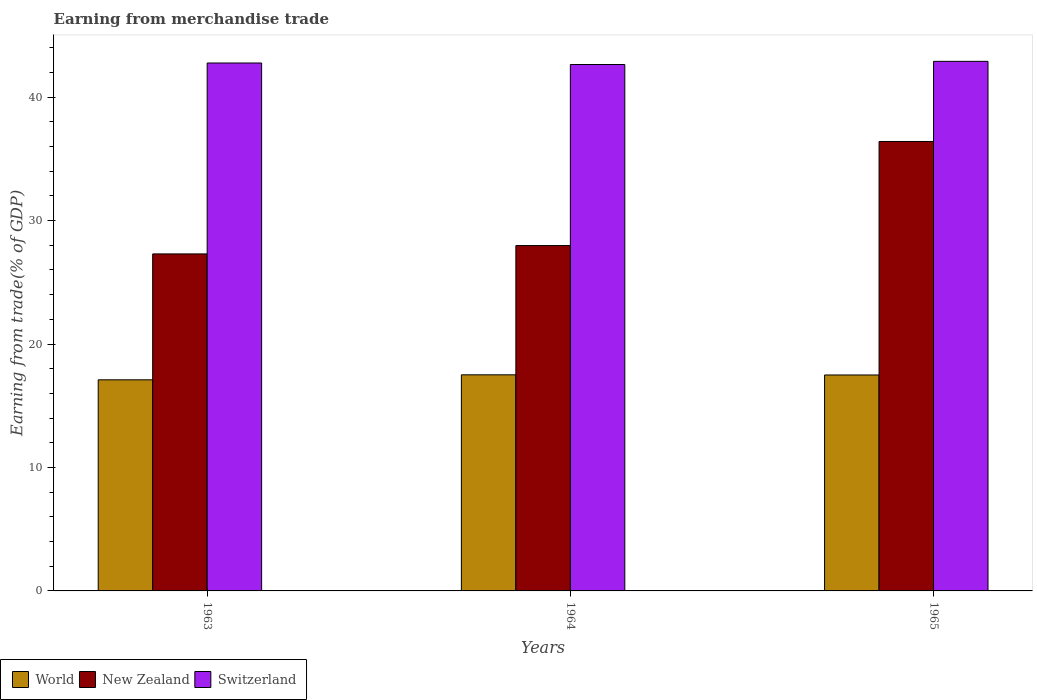How many different coloured bars are there?
Give a very brief answer. 3. Are the number of bars per tick equal to the number of legend labels?
Offer a terse response. Yes. What is the label of the 3rd group of bars from the left?
Give a very brief answer. 1965. In how many cases, is the number of bars for a given year not equal to the number of legend labels?
Your answer should be very brief. 0. What is the earnings from trade in New Zealand in 1963?
Give a very brief answer. 27.3. Across all years, what is the maximum earnings from trade in Switzerland?
Provide a short and direct response. 42.9. Across all years, what is the minimum earnings from trade in Switzerland?
Give a very brief answer. 42.64. In which year was the earnings from trade in New Zealand maximum?
Make the answer very short. 1965. In which year was the earnings from trade in World minimum?
Ensure brevity in your answer.  1963. What is the total earnings from trade in World in the graph?
Ensure brevity in your answer.  52.1. What is the difference between the earnings from trade in Switzerland in 1963 and that in 1965?
Your answer should be compact. -0.13. What is the difference between the earnings from trade in Switzerland in 1965 and the earnings from trade in World in 1963?
Provide a short and direct response. 25.8. What is the average earnings from trade in World per year?
Provide a short and direct response. 17.37. In the year 1965, what is the difference between the earnings from trade in Switzerland and earnings from trade in World?
Provide a short and direct response. 25.41. In how many years, is the earnings from trade in New Zealand greater than 28 %?
Keep it short and to the point. 1. What is the ratio of the earnings from trade in New Zealand in 1963 to that in 1965?
Your answer should be compact. 0.75. Is the difference between the earnings from trade in Switzerland in 1963 and 1964 greater than the difference between the earnings from trade in World in 1963 and 1964?
Offer a terse response. Yes. What is the difference between the highest and the second highest earnings from trade in Switzerland?
Ensure brevity in your answer.  0.13. What is the difference between the highest and the lowest earnings from trade in New Zealand?
Give a very brief answer. 9.11. What does the 1st bar from the left in 1964 represents?
Offer a terse response. World. What does the 1st bar from the right in 1963 represents?
Your response must be concise. Switzerland. Are all the bars in the graph horizontal?
Offer a very short reply. No. Does the graph contain any zero values?
Offer a terse response. No. Does the graph contain grids?
Make the answer very short. No. Where does the legend appear in the graph?
Give a very brief answer. Bottom left. How many legend labels are there?
Your answer should be very brief. 3. How are the legend labels stacked?
Give a very brief answer. Horizontal. What is the title of the graph?
Offer a terse response. Earning from merchandise trade. Does "Nicaragua" appear as one of the legend labels in the graph?
Provide a short and direct response. No. What is the label or title of the Y-axis?
Keep it short and to the point. Earning from trade(% of GDP). What is the Earning from trade(% of GDP) of World in 1963?
Give a very brief answer. 17.1. What is the Earning from trade(% of GDP) in New Zealand in 1963?
Keep it short and to the point. 27.3. What is the Earning from trade(% of GDP) in Switzerland in 1963?
Ensure brevity in your answer.  42.77. What is the Earning from trade(% of GDP) of World in 1964?
Provide a short and direct response. 17.51. What is the Earning from trade(% of GDP) of New Zealand in 1964?
Keep it short and to the point. 27.98. What is the Earning from trade(% of GDP) of Switzerland in 1964?
Your answer should be compact. 42.64. What is the Earning from trade(% of GDP) in World in 1965?
Ensure brevity in your answer.  17.49. What is the Earning from trade(% of GDP) in New Zealand in 1965?
Your response must be concise. 36.41. What is the Earning from trade(% of GDP) of Switzerland in 1965?
Ensure brevity in your answer.  42.9. Across all years, what is the maximum Earning from trade(% of GDP) of World?
Your answer should be compact. 17.51. Across all years, what is the maximum Earning from trade(% of GDP) of New Zealand?
Keep it short and to the point. 36.41. Across all years, what is the maximum Earning from trade(% of GDP) in Switzerland?
Provide a succinct answer. 42.9. Across all years, what is the minimum Earning from trade(% of GDP) of World?
Your answer should be very brief. 17.1. Across all years, what is the minimum Earning from trade(% of GDP) of New Zealand?
Keep it short and to the point. 27.3. Across all years, what is the minimum Earning from trade(% of GDP) in Switzerland?
Offer a terse response. 42.64. What is the total Earning from trade(% of GDP) in World in the graph?
Give a very brief answer. 52.1. What is the total Earning from trade(% of GDP) in New Zealand in the graph?
Your answer should be very brief. 91.69. What is the total Earning from trade(% of GDP) in Switzerland in the graph?
Keep it short and to the point. 128.31. What is the difference between the Earning from trade(% of GDP) of World in 1963 and that in 1964?
Offer a very short reply. -0.41. What is the difference between the Earning from trade(% of GDP) in New Zealand in 1963 and that in 1964?
Provide a succinct answer. -0.68. What is the difference between the Earning from trade(% of GDP) of Switzerland in 1963 and that in 1964?
Offer a very short reply. 0.12. What is the difference between the Earning from trade(% of GDP) of World in 1963 and that in 1965?
Offer a very short reply. -0.39. What is the difference between the Earning from trade(% of GDP) of New Zealand in 1963 and that in 1965?
Offer a terse response. -9.11. What is the difference between the Earning from trade(% of GDP) of Switzerland in 1963 and that in 1965?
Your answer should be compact. -0.13. What is the difference between the Earning from trade(% of GDP) of World in 1964 and that in 1965?
Ensure brevity in your answer.  0.01. What is the difference between the Earning from trade(% of GDP) of New Zealand in 1964 and that in 1965?
Provide a succinct answer. -8.43. What is the difference between the Earning from trade(% of GDP) in Switzerland in 1964 and that in 1965?
Your response must be concise. -0.26. What is the difference between the Earning from trade(% of GDP) of World in 1963 and the Earning from trade(% of GDP) of New Zealand in 1964?
Provide a short and direct response. -10.88. What is the difference between the Earning from trade(% of GDP) in World in 1963 and the Earning from trade(% of GDP) in Switzerland in 1964?
Your answer should be compact. -25.54. What is the difference between the Earning from trade(% of GDP) in New Zealand in 1963 and the Earning from trade(% of GDP) in Switzerland in 1964?
Ensure brevity in your answer.  -15.34. What is the difference between the Earning from trade(% of GDP) in World in 1963 and the Earning from trade(% of GDP) in New Zealand in 1965?
Your answer should be very brief. -19.31. What is the difference between the Earning from trade(% of GDP) of World in 1963 and the Earning from trade(% of GDP) of Switzerland in 1965?
Your answer should be compact. -25.8. What is the difference between the Earning from trade(% of GDP) in New Zealand in 1963 and the Earning from trade(% of GDP) in Switzerland in 1965?
Give a very brief answer. -15.6. What is the difference between the Earning from trade(% of GDP) in World in 1964 and the Earning from trade(% of GDP) in New Zealand in 1965?
Ensure brevity in your answer.  -18.9. What is the difference between the Earning from trade(% of GDP) in World in 1964 and the Earning from trade(% of GDP) in Switzerland in 1965?
Keep it short and to the point. -25.39. What is the difference between the Earning from trade(% of GDP) of New Zealand in 1964 and the Earning from trade(% of GDP) of Switzerland in 1965?
Provide a succinct answer. -14.92. What is the average Earning from trade(% of GDP) in World per year?
Your response must be concise. 17.37. What is the average Earning from trade(% of GDP) in New Zealand per year?
Ensure brevity in your answer.  30.56. What is the average Earning from trade(% of GDP) in Switzerland per year?
Make the answer very short. 42.77. In the year 1963, what is the difference between the Earning from trade(% of GDP) of World and Earning from trade(% of GDP) of New Zealand?
Provide a short and direct response. -10.2. In the year 1963, what is the difference between the Earning from trade(% of GDP) of World and Earning from trade(% of GDP) of Switzerland?
Provide a short and direct response. -25.67. In the year 1963, what is the difference between the Earning from trade(% of GDP) of New Zealand and Earning from trade(% of GDP) of Switzerland?
Make the answer very short. -15.47. In the year 1964, what is the difference between the Earning from trade(% of GDP) in World and Earning from trade(% of GDP) in New Zealand?
Give a very brief answer. -10.47. In the year 1964, what is the difference between the Earning from trade(% of GDP) in World and Earning from trade(% of GDP) in Switzerland?
Keep it short and to the point. -25.14. In the year 1964, what is the difference between the Earning from trade(% of GDP) of New Zealand and Earning from trade(% of GDP) of Switzerland?
Your answer should be very brief. -14.67. In the year 1965, what is the difference between the Earning from trade(% of GDP) of World and Earning from trade(% of GDP) of New Zealand?
Provide a succinct answer. -18.92. In the year 1965, what is the difference between the Earning from trade(% of GDP) in World and Earning from trade(% of GDP) in Switzerland?
Provide a succinct answer. -25.41. In the year 1965, what is the difference between the Earning from trade(% of GDP) of New Zealand and Earning from trade(% of GDP) of Switzerland?
Your answer should be compact. -6.49. What is the ratio of the Earning from trade(% of GDP) of World in 1963 to that in 1964?
Your answer should be very brief. 0.98. What is the ratio of the Earning from trade(% of GDP) in New Zealand in 1963 to that in 1964?
Keep it short and to the point. 0.98. What is the ratio of the Earning from trade(% of GDP) in World in 1963 to that in 1965?
Give a very brief answer. 0.98. What is the ratio of the Earning from trade(% of GDP) in New Zealand in 1963 to that in 1965?
Provide a succinct answer. 0.75. What is the ratio of the Earning from trade(% of GDP) of New Zealand in 1964 to that in 1965?
Make the answer very short. 0.77. What is the ratio of the Earning from trade(% of GDP) in Switzerland in 1964 to that in 1965?
Ensure brevity in your answer.  0.99. What is the difference between the highest and the second highest Earning from trade(% of GDP) in World?
Keep it short and to the point. 0.01. What is the difference between the highest and the second highest Earning from trade(% of GDP) in New Zealand?
Offer a terse response. 8.43. What is the difference between the highest and the second highest Earning from trade(% of GDP) of Switzerland?
Your answer should be compact. 0.13. What is the difference between the highest and the lowest Earning from trade(% of GDP) in World?
Ensure brevity in your answer.  0.41. What is the difference between the highest and the lowest Earning from trade(% of GDP) of New Zealand?
Your response must be concise. 9.11. What is the difference between the highest and the lowest Earning from trade(% of GDP) of Switzerland?
Provide a short and direct response. 0.26. 